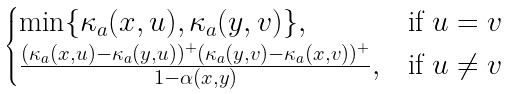<formula> <loc_0><loc_0><loc_500><loc_500>\begin{cases} \min \{ \kappa _ { a } ( x , u ) , \kappa _ { a } ( y , v ) \} , & \text {if $u=v$} \\ \frac { ( \kappa _ { a } ( x , u ) - \kappa _ { a } ( y , u ) ) ^ { + } ( \kappa _ { a } ( y , v ) - \kappa _ { a } ( x , v ) ) ^ { + } } { 1 - \alpha ( x , y ) } , & \text {if $u\not= v$} \end{cases}</formula> 